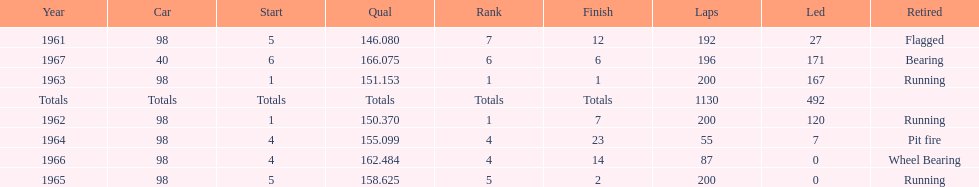In which years did he lead the race the least? 1965, 1966. 